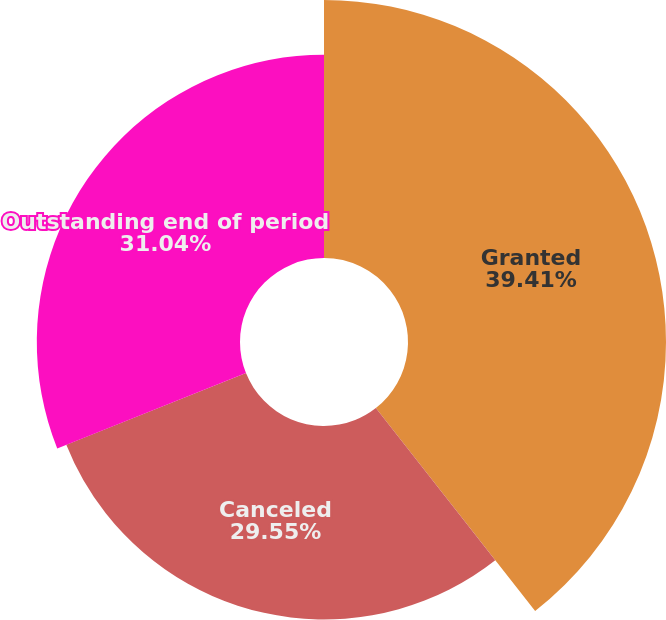Convert chart. <chart><loc_0><loc_0><loc_500><loc_500><pie_chart><fcel>Granted<fcel>Canceled<fcel>Outstanding end of period<nl><fcel>39.41%<fcel>29.55%<fcel>31.04%<nl></chart> 